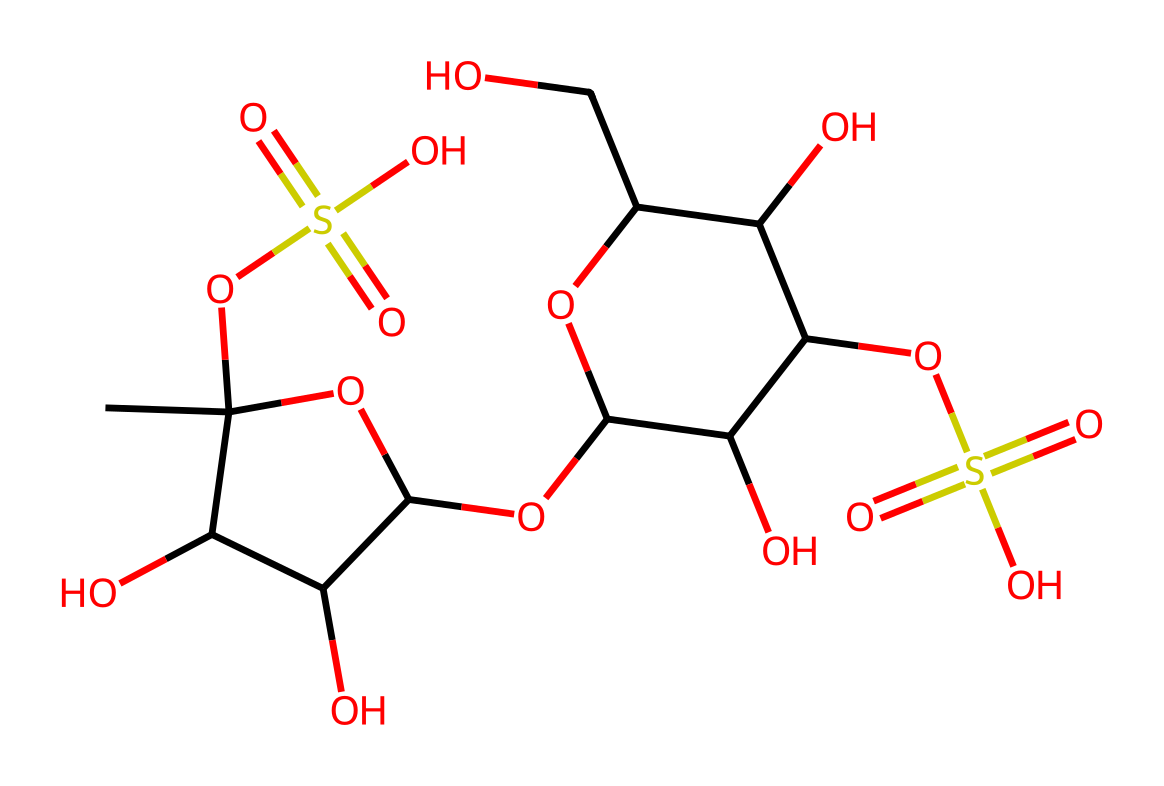What is the main functional group present in carrageenan? The structure contains sulfate groups (OS(=O)(=O)O) that are prominent in the molecule, indicating its sulfate nature.
Answer: sulfate How many hydroxyl (-OH) groups are present in the structure? By examining the structure, there are multiple -OH groups attached to various carbon atoms. Counting them, there are five hydroxyl groups present in the molecule.
Answer: five What type of polymer is carrageenan classified as? The structure shows that it consists of repeating sugar units with sulfate modifications, classifying it as a polysaccharide.
Answer: polysaccharide What is the total number of carbon atoms in the structure? The SMILES representation indicates the presence of various carbon chains and rings; counting the carbon atoms in the structure results in a total of 11 carbon atoms.
Answer: eleven What characteristic of carrageenan contributes to its use in biodegradable films? Carrageenan's chemical structure, particularly the presence of sulfated polysaccharides, provides a gelatinous property that aids in film-forming, which is essential for biodegradable applications.
Answer: gelatinous property What is the significance of sulfate groups in carrageenan? The sulfate groups not only contribute to the ionic interactions within the material but also improve the water solubility and viscosity, making the polymer suitable for various applications including food and packaging.
Answer: improve solubility 